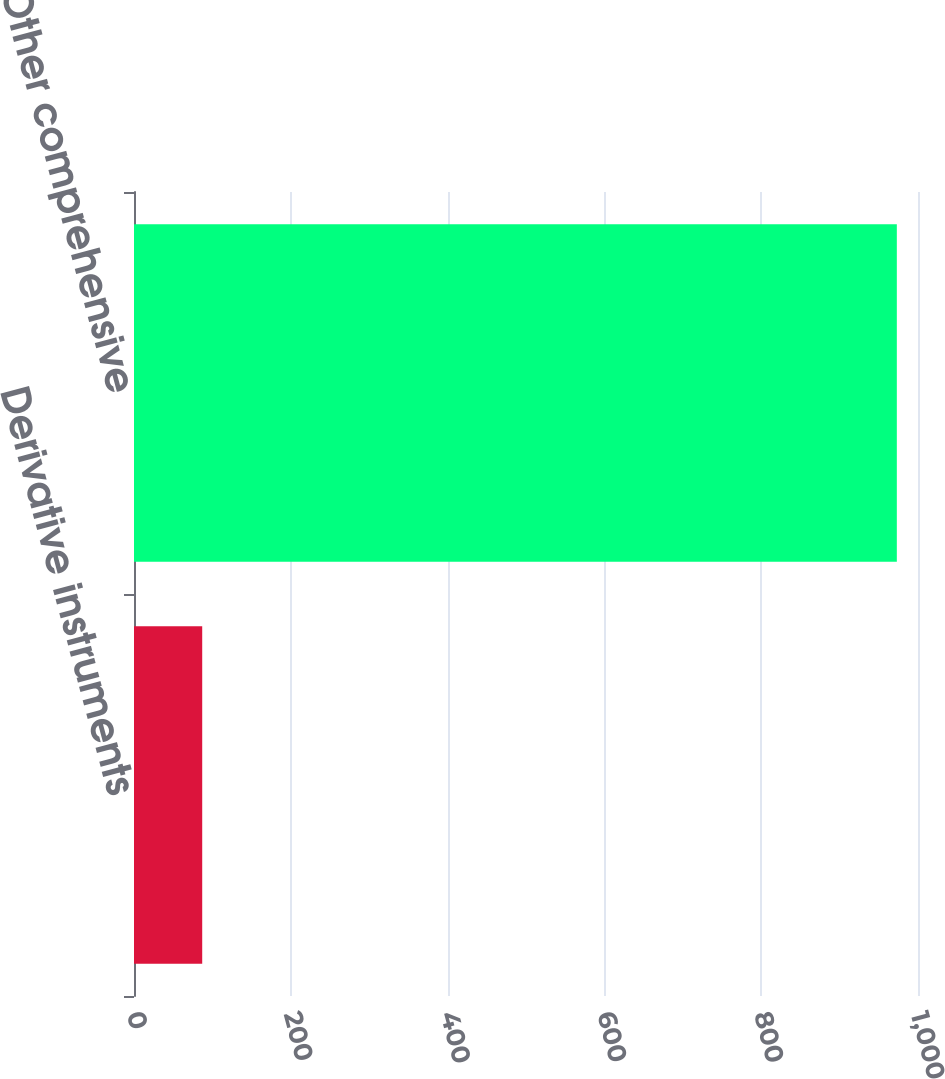Convert chart. <chart><loc_0><loc_0><loc_500><loc_500><bar_chart><fcel>Derivative instruments<fcel>Other comprehensive<nl><fcel>87<fcel>973<nl></chart> 